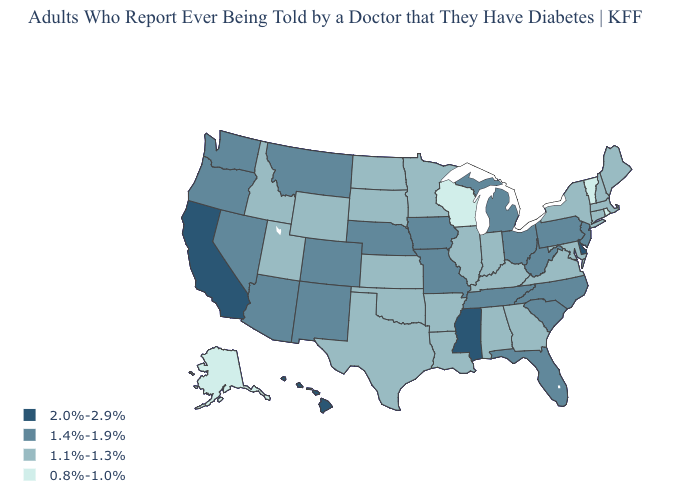What is the highest value in states that border Colorado?
Short answer required. 1.4%-1.9%. What is the value of Arkansas?
Concise answer only. 1.1%-1.3%. What is the lowest value in the USA?
Keep it brief. 0.8%-1.0%. Name the states that have a value in the range 0.8%-1.0%?
Keep it brief. Alaska, Rhode Island, Vermont, Wisconsin. Which states have the lowest value in the USA?
Keep it brief. Alaska, Rhode Island, Vermont, Wisconsin. Which states have the lowest value in the West?
Short answer required. Alaska. Does Louisiana have the highest value in the South?
Write a very short answer. No. Does New Jersey have the highest value in the Northeast?
Quick response, please. Yes. What is the value of California?
Give a very brief answer. 2.0%-2.9%. Does California have the highest value in the USA?
Quick response, please. Yes. Does Colorado have the same value as New Mexico?
Concise answer only. Yes. Name the states that have a value in the range 1.1%-1.3%?
Answer briefly. Alabama, Arkansas, Connecticut, Georgia, Idaho, Illinois, Indiana, Kansas, Kentucky, Louisiana, Maine, Maryland, Massachusetts, Minnesota, New Hampshire, New York, North Dakota, Oklahoma, South Dakota, Texas, Utah, Virginia, Wyoming. Among the states that border Michigan , does Ohio have the highest value?
Concise answer only. Yes. Name the states that have a value in the range 1.1%-1.3%?
Give a very brief answer. Alabama, Arkansas, Connecticut, Georgia, Idaho, Illinois, Indiana, Kansas, Kentucky, Louisiana, Maine, Maryland, Massachusetts, Minnesota, New Hampshire, New York, North Dakota, Oklahoma, South Dakota, Texas, Utah, Virginia, Wyoming. Does South Carolina have a higher value than Oregon?
Answer briefly. No. 